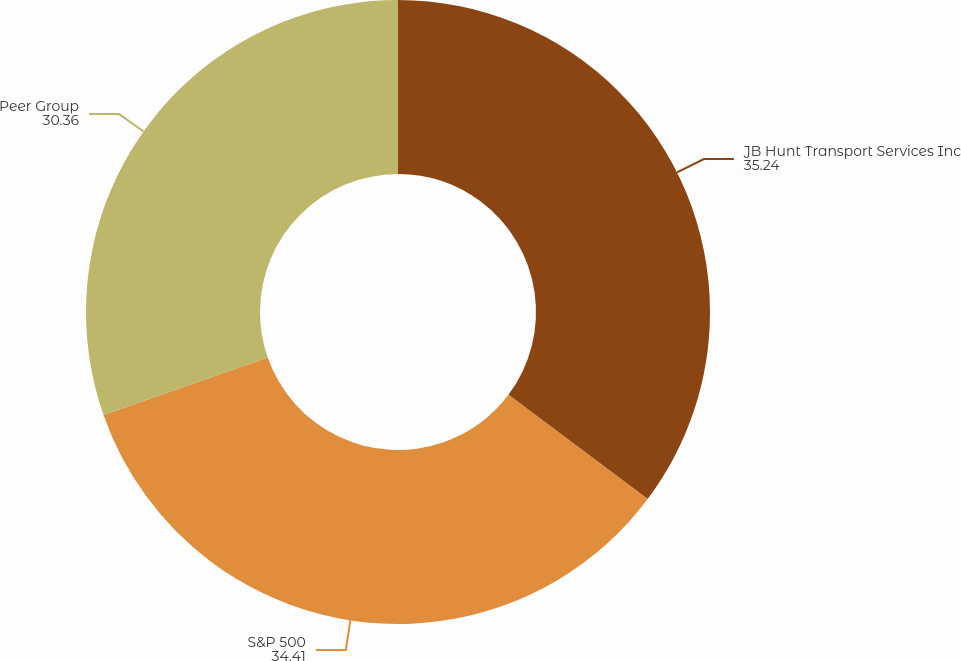Convert chart. <chart><loc_0><loc_0><loc_500><loc_500><pie_chart><fcel>JB Hunt Transport Services Inc<fcel>S&P 500<fcel>Peer Group<nl><fcel>35.24%<fcel>34.41%<fcel>30.36%<nl></chart> 